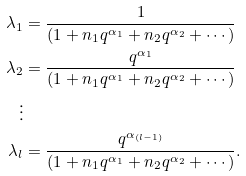<formula> <loc_0><loc_0><loc_500><loc_500>\lambda _ { 1 } & = \frac { 1 } { ( 1 + n _ { 1 } q ^ { \alpha _ { 1 } } + n _ { 2 } q ^ { \alpha _ { 2 } } + \cdots ) } \\ \lambda _ { 2 } & = \frac { q ^ { \alpha _ { 1 } } } { ( 1 + n _ { 1 } q ^ { \alpha _ { 1 } } + n _ { 2 } q ^ { \alpha _ { 2 } } + \cdots ) } \\ \vdots \\ \lambda _ { l } & = \frac { q ^ { \alpha _ { ( l - 1 ) } } } { ( 1 + n _ { 1 } q ^ { \alpha _ { 1 } } + n _ { 2 } q ^ { \alpha _ { 2 } } + \cdots ) } .</formula> 